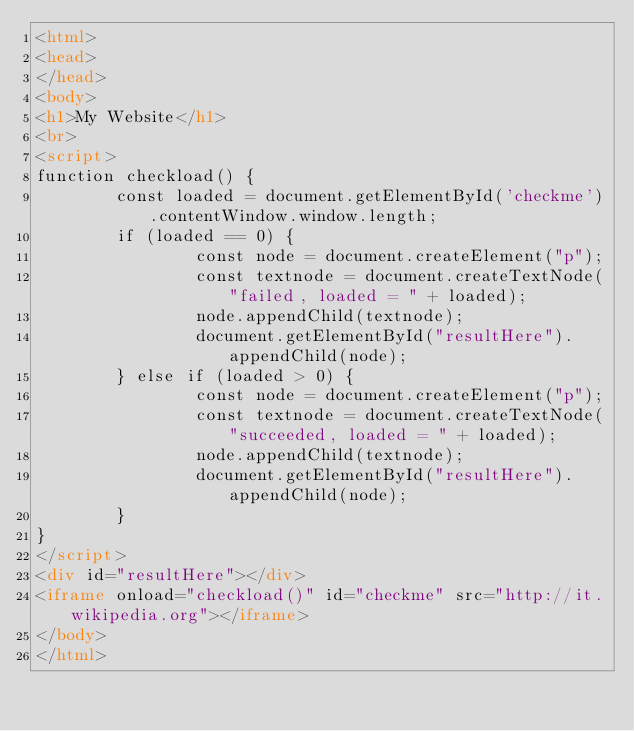<code> <loc_0><loc_0><loc_500><loc_500><_HTML_><html>
<head>
</head>
<body>
<h1>My Website</h1>
<br>
<script>
function checkload() {
        const loaded = document.getElementById('checkme').contentWindow.window.length;
        if (loaded == 0) {
                const node = document.createElement("p");
                const textnode = document.createTextNode("failed, loaded = " + loaded);
                node.appendChild(textnode);
                document.getElementById("resultHere").appendChild(node);
        } else if (loaded > 0) {
                const node = document.createElement("p");
                const textnode = document.createTextNode("succeeded, loaded = " + loaded);
                node.appendChild(textnode);
                document.getElementById("resultHere").appendChild(node);
        }
}
</script>
<div id="resultHere"></div>
<iframe onload="checkload()" id="checkme" src="http://it.wikipedia.org"></iframe>
</body>
</html>
</code> 